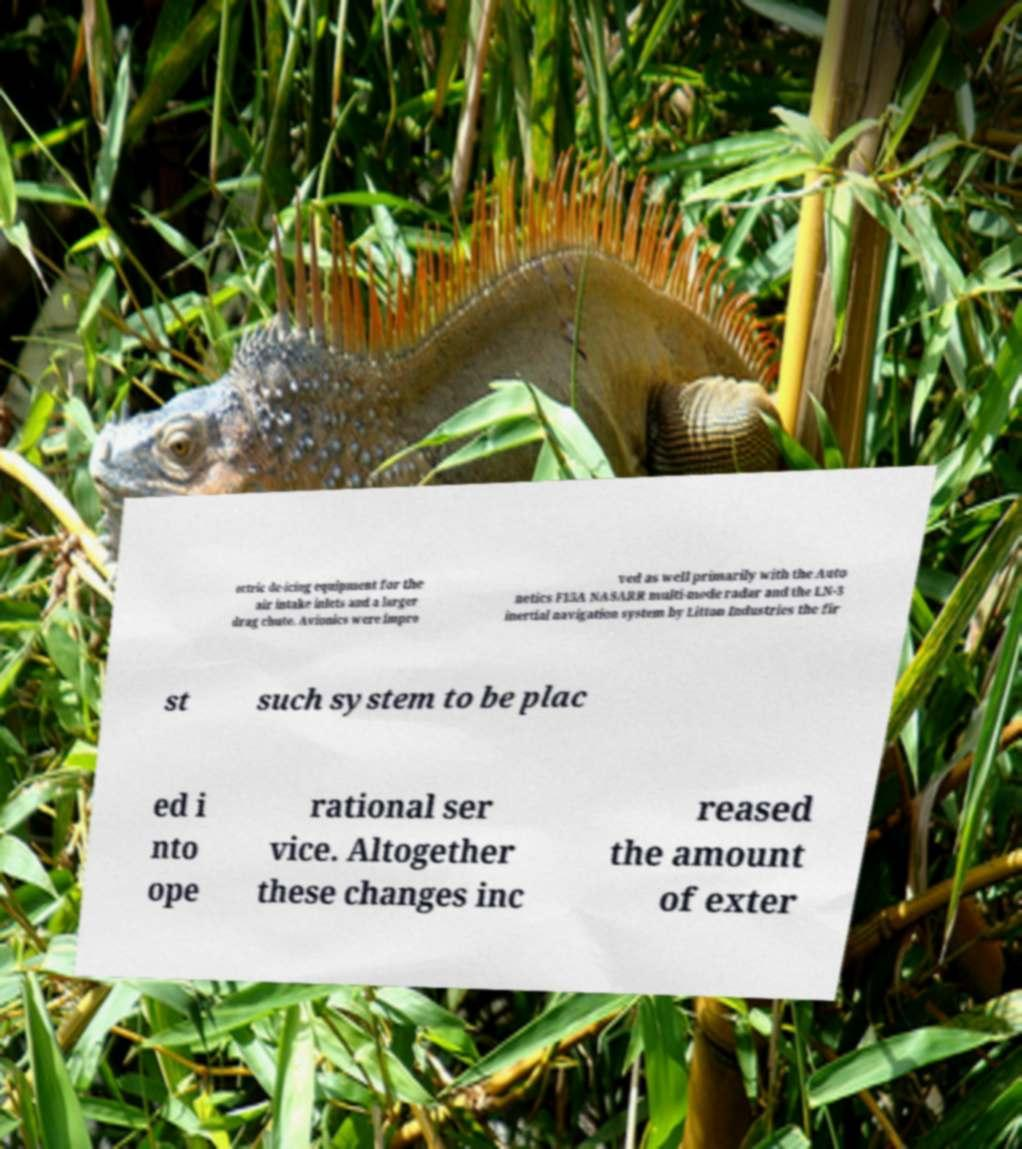There's text embedded in this image that I need extracted. Can you transcribe it verbatim? ectric de-icing equipment for the air intake inlets and a larger drag chute. Avionics were impro ved as well primarily with the Auto netics F15A NASARR multi-mode radar and the LN-3 inertial navigation system by Litton Industries the fir st such system to be plac ed i nto ope rational ser vice. Altogether these changes inc reased the amount of exter 